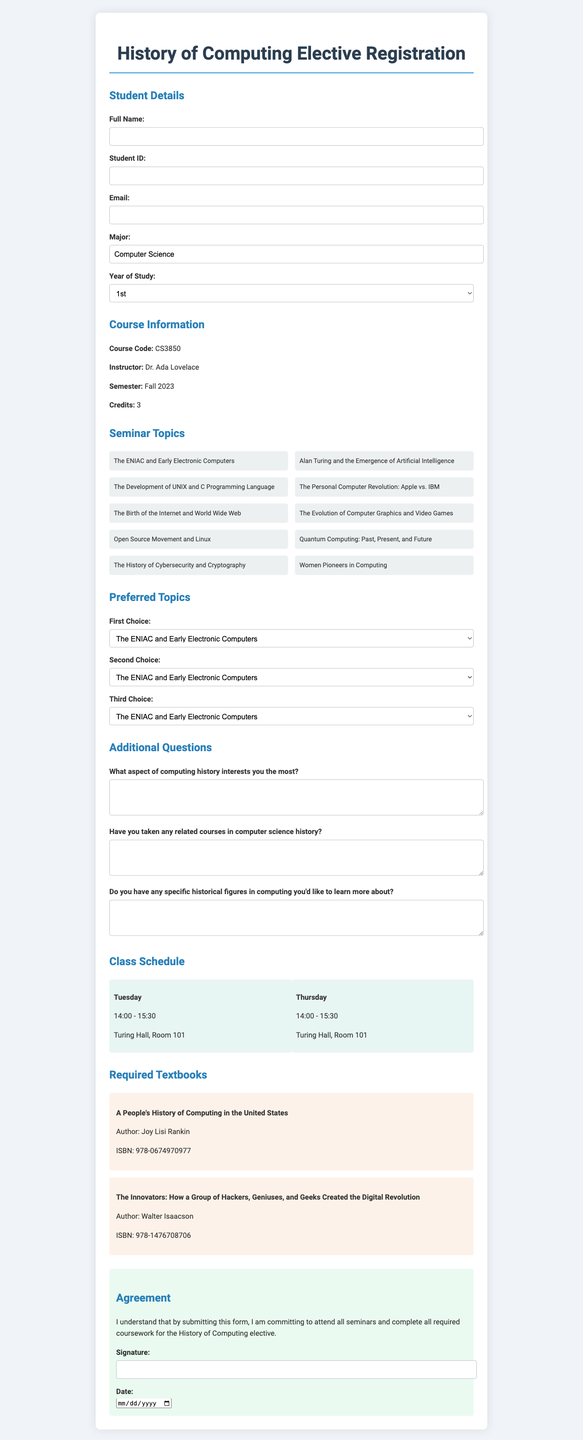What is the course code? The course code is mentioned in the course information section of the document.
Answer: CS3850 Who is the instructor for the course? The instructor's name is provided alongside the course information.
Answer: Dr. Ada Lovelace What are the seminar topics available? The seminar topics are listed under the seminar topics section.
Answer: The ENIAC and Early Electronic Computers; Alan Turing and the Emergence of Artificial Intelligence; The Development of UNIX and C Programming Language; The Personal Computer Revolution: Apple vs. IBM; The Birth of the Internet and World Wide Web; The Evolution of Computer Graphics and Video Games; Open Source Movement and Linux; Quantum Computing: Past, Present, and Future; The History of Cybersecurity and Cryptography; Women Pioneers in Computing How many credits is the course worth? The credits for the course are specified in the course information section.
Answer: 3 What day and time is the class scheduled? The class schedule details the specific days and times for sessions.
Answer: Tuesday and Thursday, 14:00 - 15:30 What is the required textbook by Joy Lisi Rankin? The title and author of the textbook are noted under the required textbooks section.
Answer: A People's History of Computing in the United States What is each student committing to by submitting the form? The agreement section outlines the student's commitment upon submission.
Answer: Attend all seminars and complete all required coursework What is the maximum year of study a student can select? The year of study options are provided in a dropdown menu in the student details section.
Answer: 5th+ What are the first three choices for preferred seminar topics? The preferred topics sections allow students to select their top three choices.
Answer: First Choice, Second Choice, Third Choice What is the location of the class? The class schedule lists the location of the seminar sessions.
Answer: Turing Hall, Room 101 